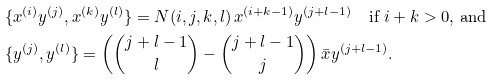<formula> <loc_0><loc_0><loc_500><loc_500>& \{ x ^ { ( i ) } y ^ { ( j ) } , x ^ { ( k ) } y ^ { ( l ) } \} = N ( i , j , k , l ) \, x ^ { ( i + k - 1 ) } y ^ { ( j + l - 1 ) } \quad \text {if $i+k>0$, and} \\ & \{ y ^ { ( j ) } , y ^ { ( l ) } \} = \left ( \binom { j + l - 1 } { l } - \binom { j + l - 1 } { j } \right ) \bar { x } y ^ { ( j + l - 1 ) } .</formula> 